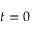<formula> <loc_0><loc_0><loc_500><loc_500>t = 0</formula> 